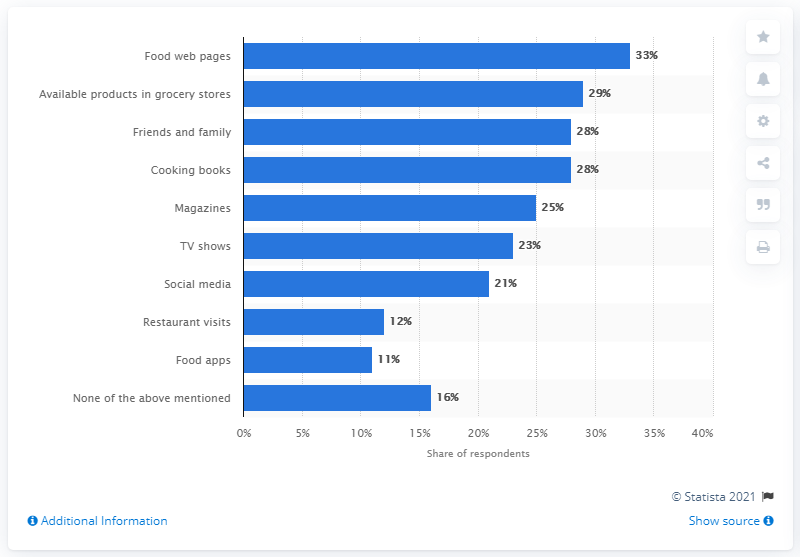Give some essential details in this illustration. According to the survey results, a significant proportion of respondents reported that they were inspired by food web pages to create dinner recipes. According to the survey results, 33% of respondents cited food web pages as their primary source of inspiration for dinner recipes. 